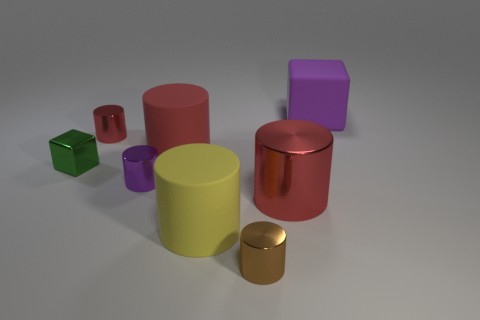Is there a tiny metallic thing that has the same shape as the yellow rubber object? Indeed, there is a small metallic object that shares the cylindrical shape with the larger, yellow rubber-like object. 